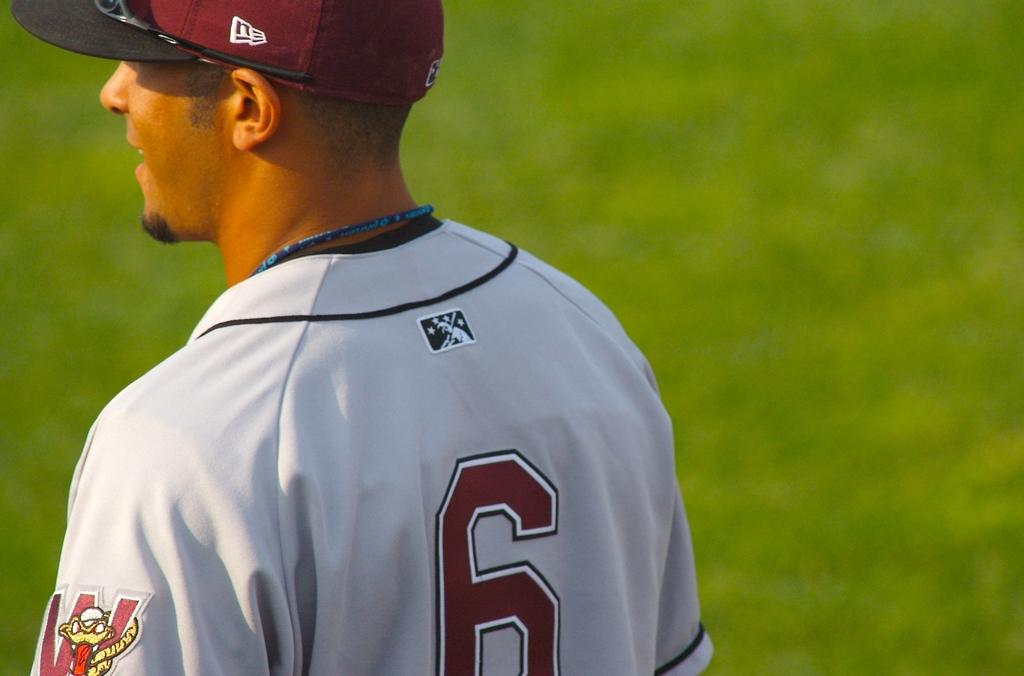Provide a one-sentence caption for the provided image. A baseball player in a number 6 jersey is standing on a field. 